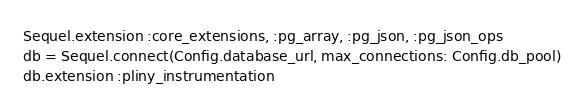Convert code to text. <code><loc_0><loc_0><loc_500><loc_500><_Ruby_>Sequel.extension :core_extensions, :pg_array, :pg_json, :pg_json_ops
db = Sequel.connect(Config.database_url, max_connections: Config.db_pool)
db.extension :pliny_instrumentation</code> 